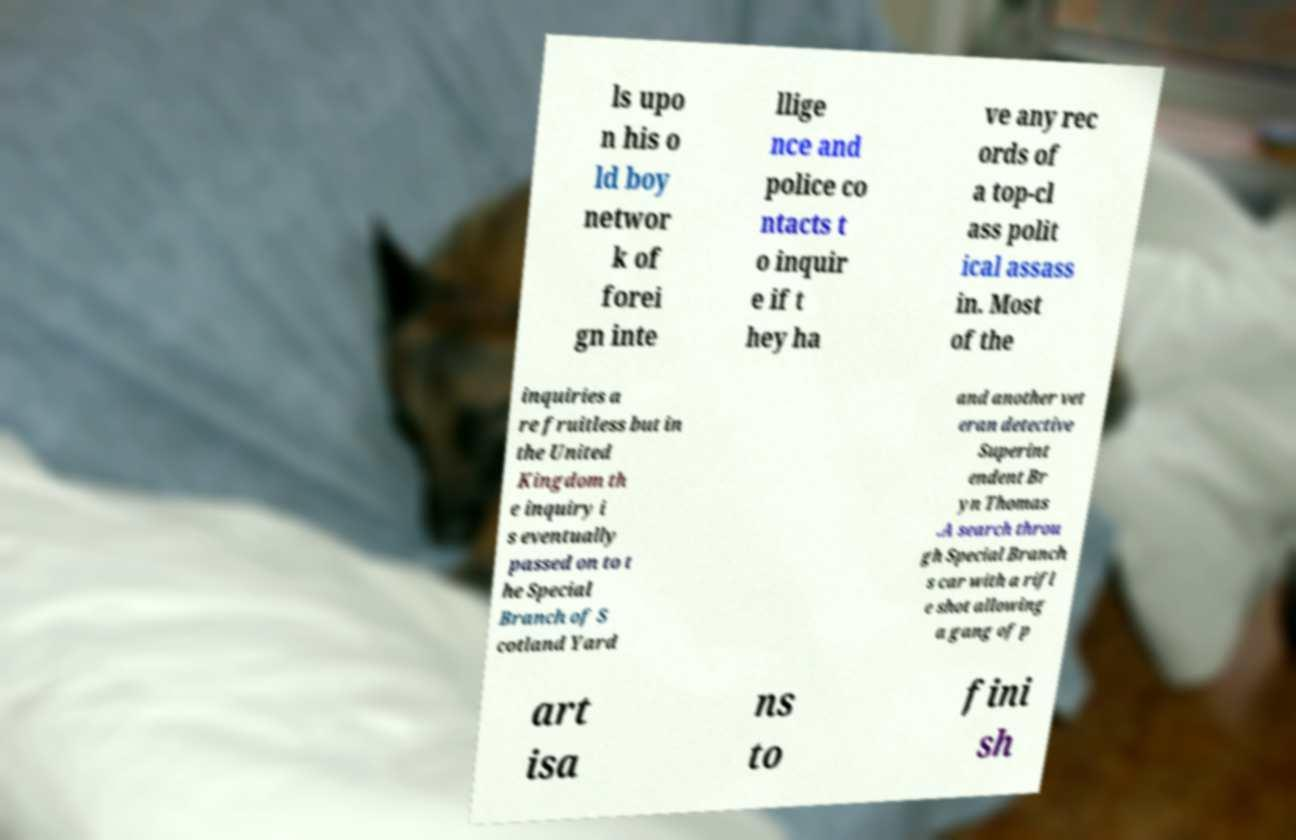For documentation purposes, I need the text within this image transcribed. Could you provide that? ls upo n his o ld boy networ k of forei gn inte llige nce and police co ntacts t o inquir e if t hey ha ve any rec ords of a top-cl ass polit ical assass in. Most of the inquiries a re fruitless but in the United Kingdom th e inquiry i s eventually passed on to t he Special Branch of S cotland Yard and another vet eran detective Superint endent Br yn Thomas .A search throu gh Special Branch s car with a rifl e shot allowing a gang of p art isa ns to fini sh 